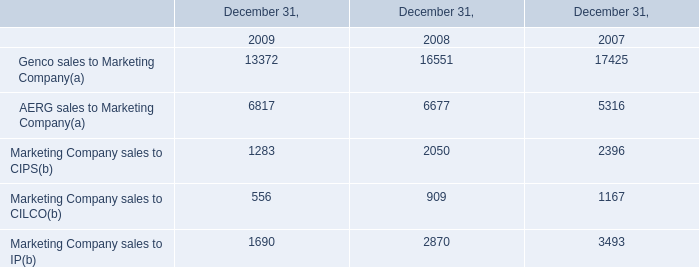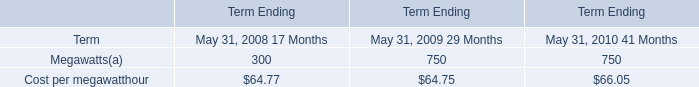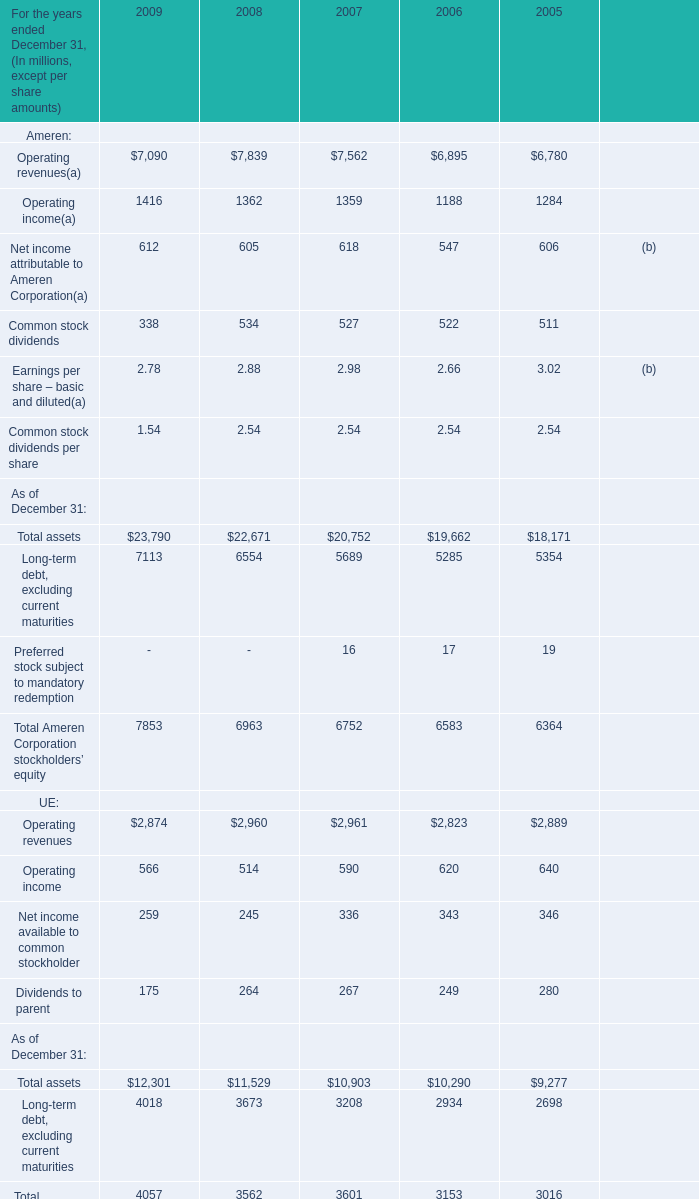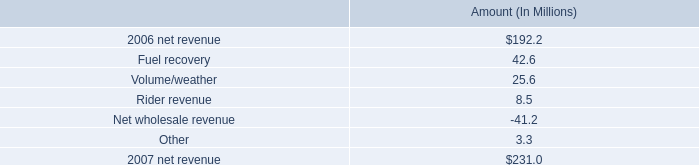what is the growth rate in net revenue in 2007 compare to 2006 for entergy new orleans , inc.? 
Computations: ((231.0 - 192.2) / 192.2)
Answer: 0.20187. 